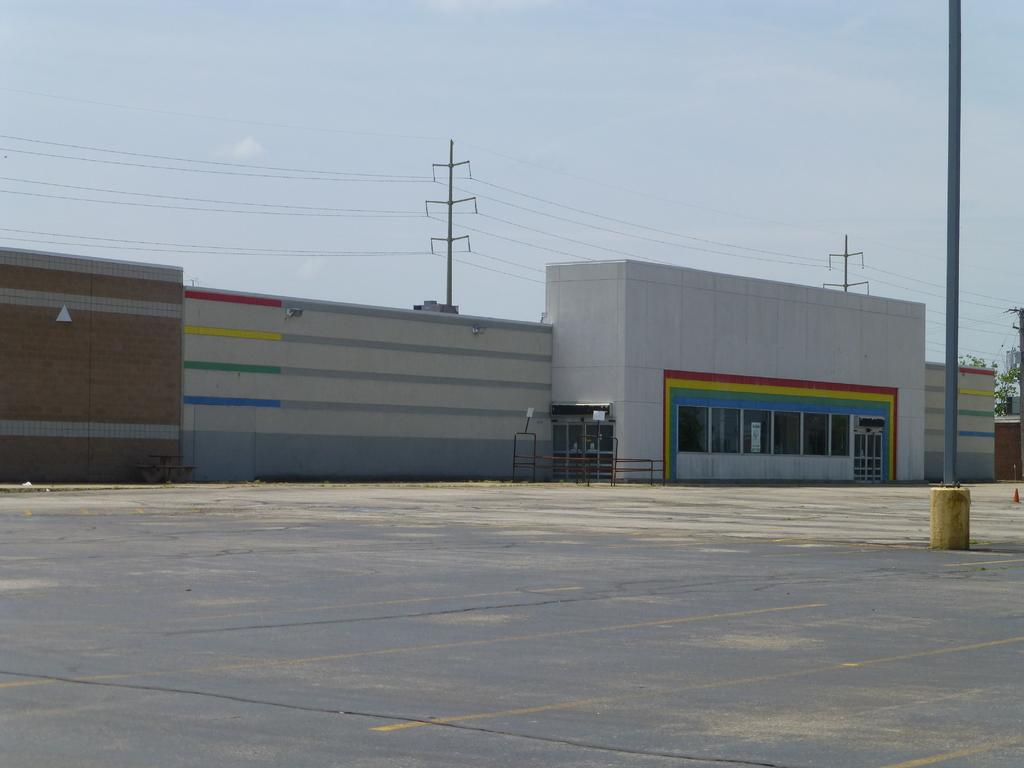What type of structures can be seen in the image? There are buildings in the image. What else is present in the image besides the buildings? There are wires and poles in the image. What can be seen in the background of the image? The sky is visible in the background of the image. How many times does the floor rotate in the image? There is no floor present in the image, as it is an outdoor scene with buildings, wires, poles, and the sky visible. 